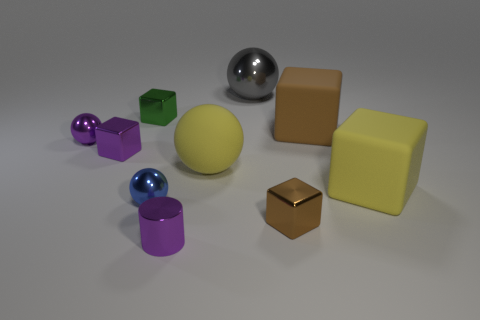How many tiny metallic things are both in front of the large yellow rubber sphere and to the left of the large yellow ball?
Offer a terse response. 2. Are there any other tiny cylinders made of the same material as the tiny purple cylinder?
Keep it short and to the point. No. What is the material of the brown object behind the brown object that is in front of the yellow matte ball?
Offer a terse response. Rubber. Are there the same number of gray things behind the tiny green metal cube and yellow rubber spheres behind the small shiny cylinder?
Offer a terse response. Yes. Do the big metal thing and the blue metallic object have the same shape?
Offer a terse response. Yes. There is a ball that is on the right side of the metallic cylinder and on the left side of the large gray metal sphere; what material is it made of?
Give a very brief answer. Rubber. How many large yellow rubber things are the same shape as the big gray shiny object?
Your answer should be compact. 1. There is a brown object in front of the matte thing behind the sphere that is to the left of the tiny blue object; what size is it?
Make the answer very short. Small. Are there more green shiny cubes that are behind the big yellow block than green rubber balls?
Offer a terse response. Yes. Are there any cyan matte cylinders?
Provide a short and direct response. No. 